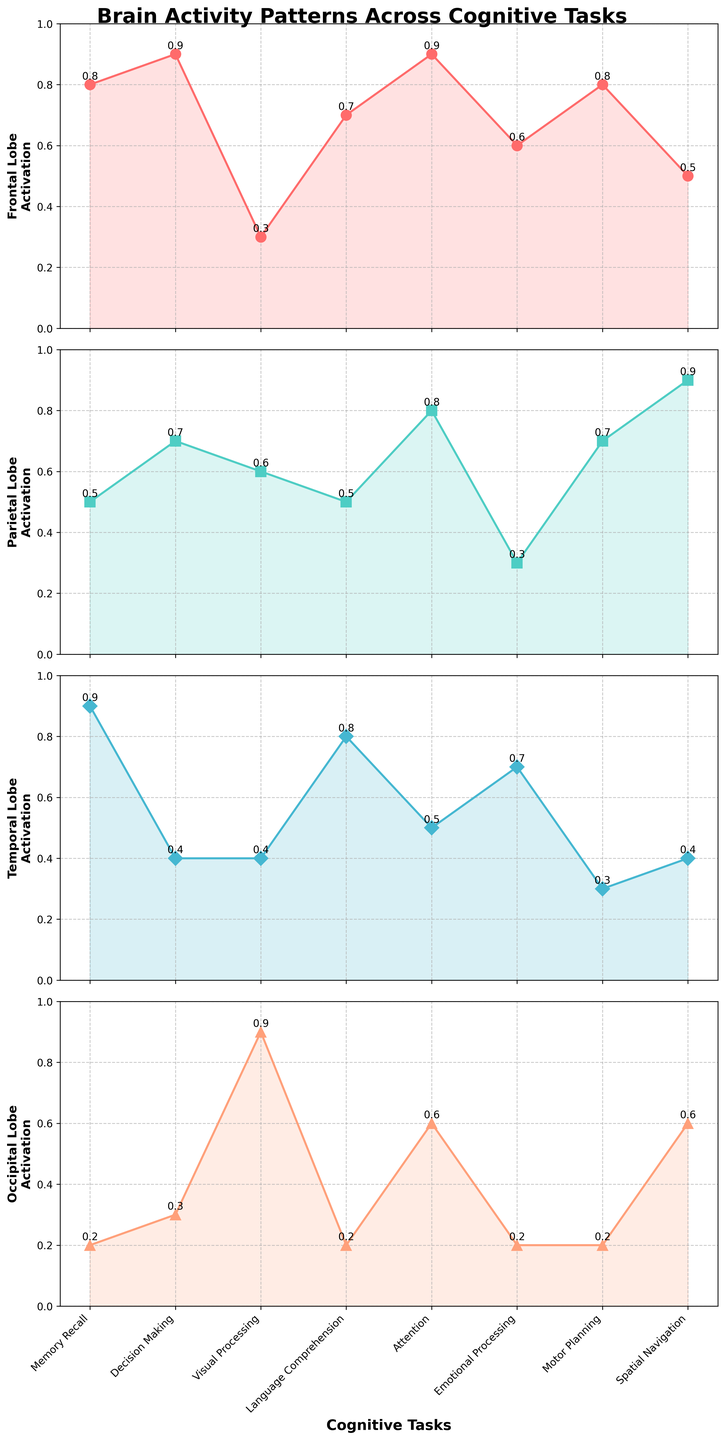What is the highest activation value observed in the Frontal Lobe? Look at the Frontal Lobe subplot and find the highest data point, which corresponds to Decision Making and Attention tasks with a value of 0.9
Answer: 0.9 Which cognitive task has the lowest activation in the Occipital Lobe? Inspect the Occipital Lobe subplot and identify the lowest point, which corresponds to Memory Recall, Language Comprehension, Emotional Processing, and Motor Planning tasks with the same value of 0.2
Answer: Memory Recall What is the average activation level of the Parietal Lobe across all tasks? Add the activation values for the Parietal Lobe (0.5, 0.7, 0.6, 0.5, 0.8, 0.3, 0.7, 0.9) and then divide by the number of tasks (8): (0.5+0.7+0.6+0.5+0.8+0.3+0.7+0.9)/8 = 0.625
Answer: 0.6 Which lobe shows the highest variability in activation across tasks? Compare the range (difference between the highest and lowest values) of activations in each lobe. Frontal Lobe: 0.9 - 0.3 = 0.6, Parietal Lobe: 0.9 - 0.3 = 0.6, Temporal Lobe: 0.9 - 0.3 = 0.6, Occipital Lobe: 0.9 - 0.2 = 0.7. Hence, the Occipital Lobe has the highest variability.
Answer: Occipital Lobe How does activation in the Temporal Lobe for Language Comprehension compare to Visual Processing? Observe the Temporal Lobe subplot for Language Comprehension (0.8) and Visual Processing (0.4) tasks. Language Comprehension has a higher activation.
Answer: Higher Which task shows equal activation levels in the Frontal and Temporal Lobes? Compare the Frontal and Temporal Lobe subplots to identify the same values. Memory Recall shows equal activation of 0.8 in both lobes.
Answer: Memory Recall In which cognitive task does the Parietal Lobe have the highest activation? Look for the highest data point in the Parietal Lobe subplot, which is during Spatial Navigation at 0.9.
Answer: Spatial Navigation Calculate the difference in activation for the Frontal Lobe between Decision Making and Emotional Processing tasks. Frontal Lobe activation for Decision Making is 0.9 and for Emotional Processing is 0.6. The difference is 0.9 - 0.6 = 0.3
Answer: 0.3 Is there any cognitive task where the Frontal, Parietal, and Temporal Lobes all have activation values greater than 0.5? Check tasks across Frontal, Parietal, and Temporal Lobes for values greater than 0.5. Attention has values of Frontal (0.9), Parietal (0.8), and Temporal (0.5); none meet the criteria in Temporal Lobe. Language Comprehension meets the criteria across all required brain regions.
Answer: No Which cognitive task demonstrates the highest activation in one of the brain lobes? Examine each subplot for the highest activation values. Occipital Lobe during Visual Processing shows 0.9, which is the highest value among all lobes and tasks.
Answer: Visual Processing 